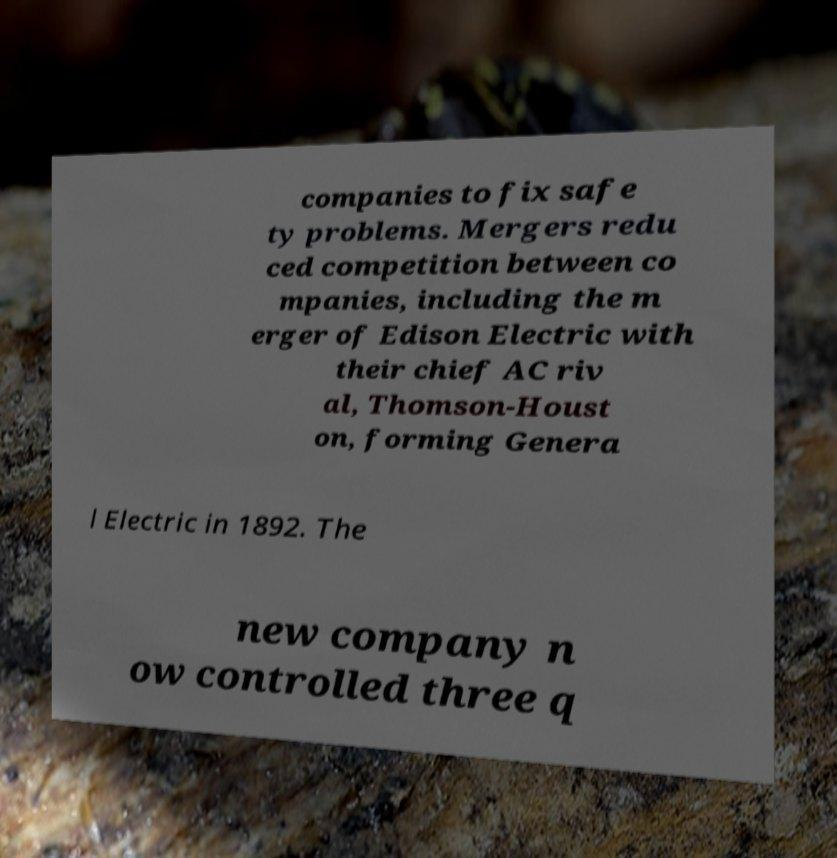What messages or text are displayed in this image? I need them in a readable, typed format. companies to fix safe ty problems. Mergers redu ced competition between co mpanies, including the m erger of Edison Electric with their chief AC riv al, Thomson-Houst on, forming Genera l Electric in 1892. The new company n ow controlled three q 